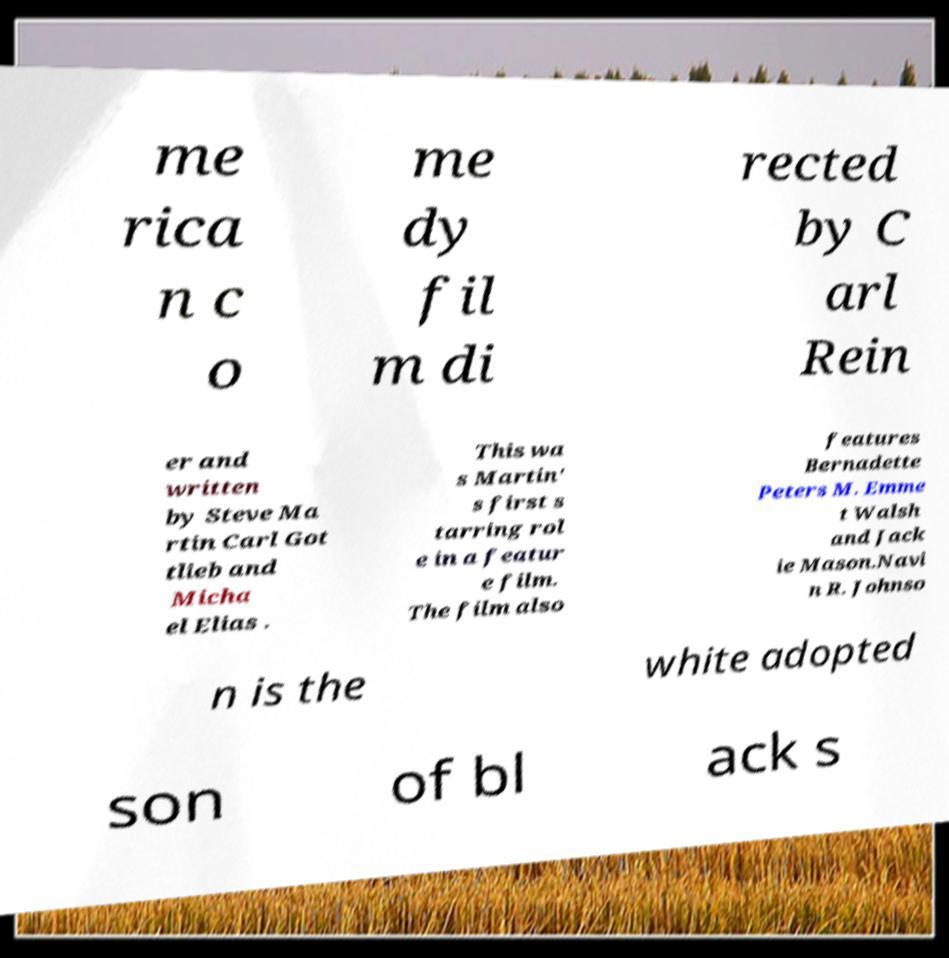Could you extract and type out the text from this image? me rica n c o me dy fil m di rected by C arl Rein er and written by Steve Ma rtin Carl Got tlieb and Micha el Elias . This wa s Martin' s first s tarring rol e in a featur e film. The film also features Bernadette Peters M. Emme t Walsh and Jack ie Mason.Navi n R. Johnso n is the white adopted son of bl ack s 